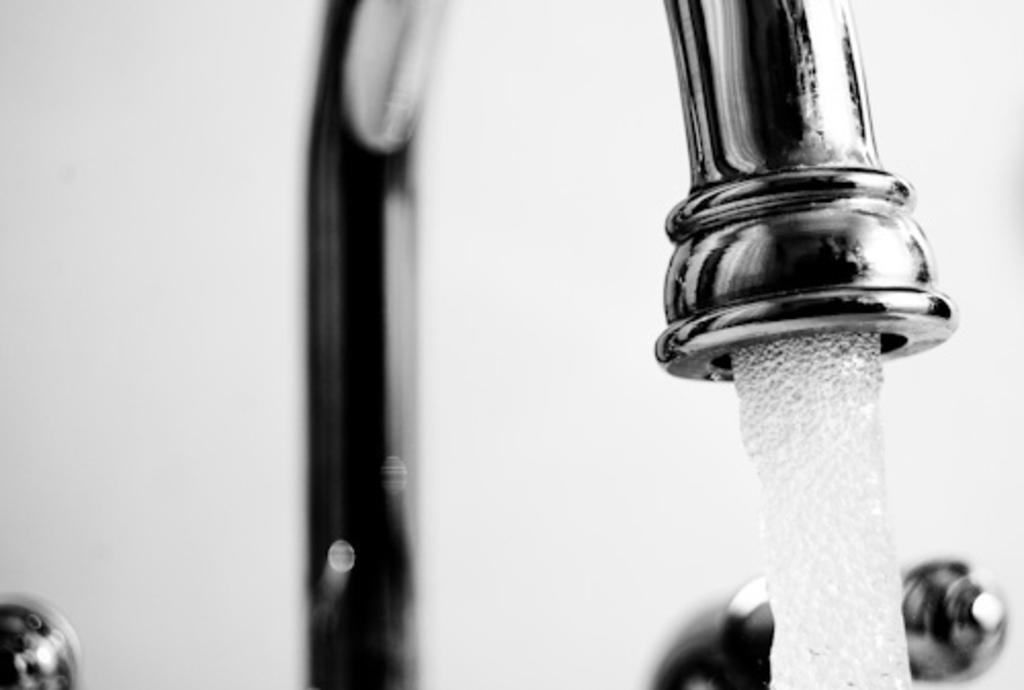What is the color scheme of the image? The image is black and white. What can be seen coming out of the tap in the image? Water is coming through the tap in the image. What is visible in the background of the image? There is a wall visible in the background of the image. How many balls are bouncing on the rail in the image? There are no balls or rails present in the image. What type of heat source can be seen in the image? There is no heat source visible in the image. 